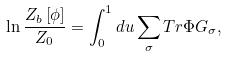Convert formula to latex. <formula><loc_0><loc_0><loc_500><loc_500>\ln \frac { Z _ { b } \left [ \phi \right ] } { Z _ { 0 } } = \int _ { 0 } ^ { 1 } d u \sum _ { \sigma } T r \Phi G _ { \sigma } ,</formula> 